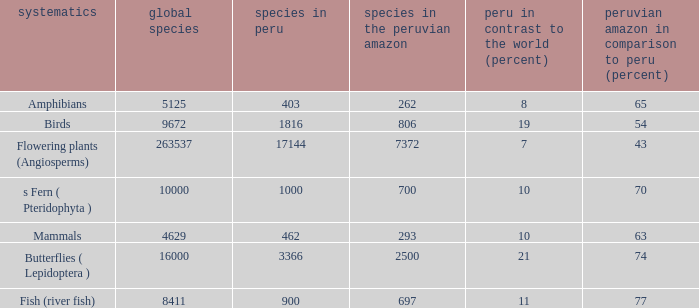What's the minimum species in the peruvian amazon with taxonomy s fern ( pteridophyta ) 700.0. 